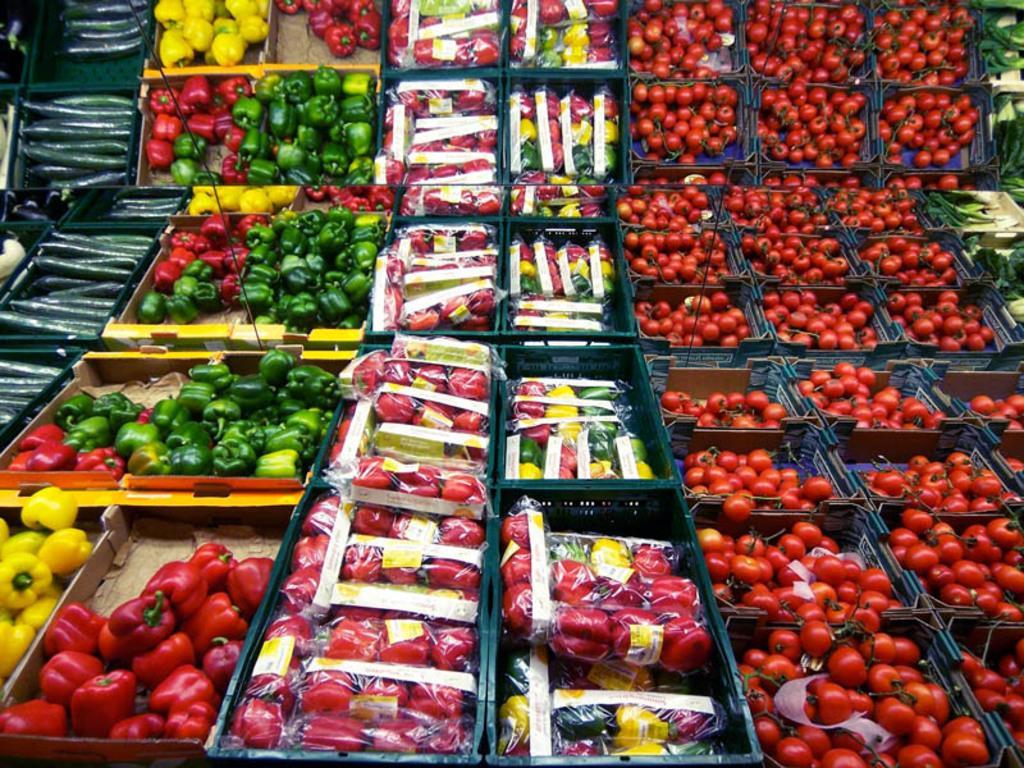Could you give a brief overview of what you see in this image? In this image, we can see baskets contains some vegetables. 